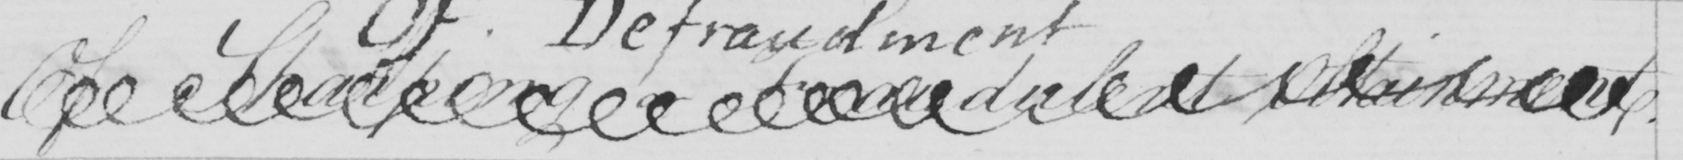Please provide the text content of this handwritten line. Of Sharping or Fraudulent Obtainment . 